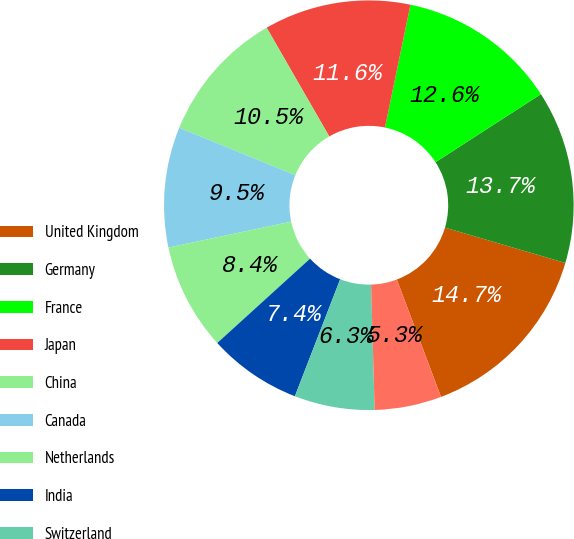<chart> <loc_0><loc_0><loc_500><loc_500><pie_chart><fcel>United Kingdom<fcel>Germany<fcel>France<fcel>Japan<fcel>China<fcel>Canada<fcel>Netherlands<fcel>India<fcel>Switzerland<fcel>Korea<nl><fcel>14.72%<fcel>13.67%<fcel>12.62%<fcel>11.57%<fcel>10.52%<fcel>9.48%<fcel>8.43%<fcel>7.38%<fcel>6.33%<fcel>5.28%<nl></chart> 